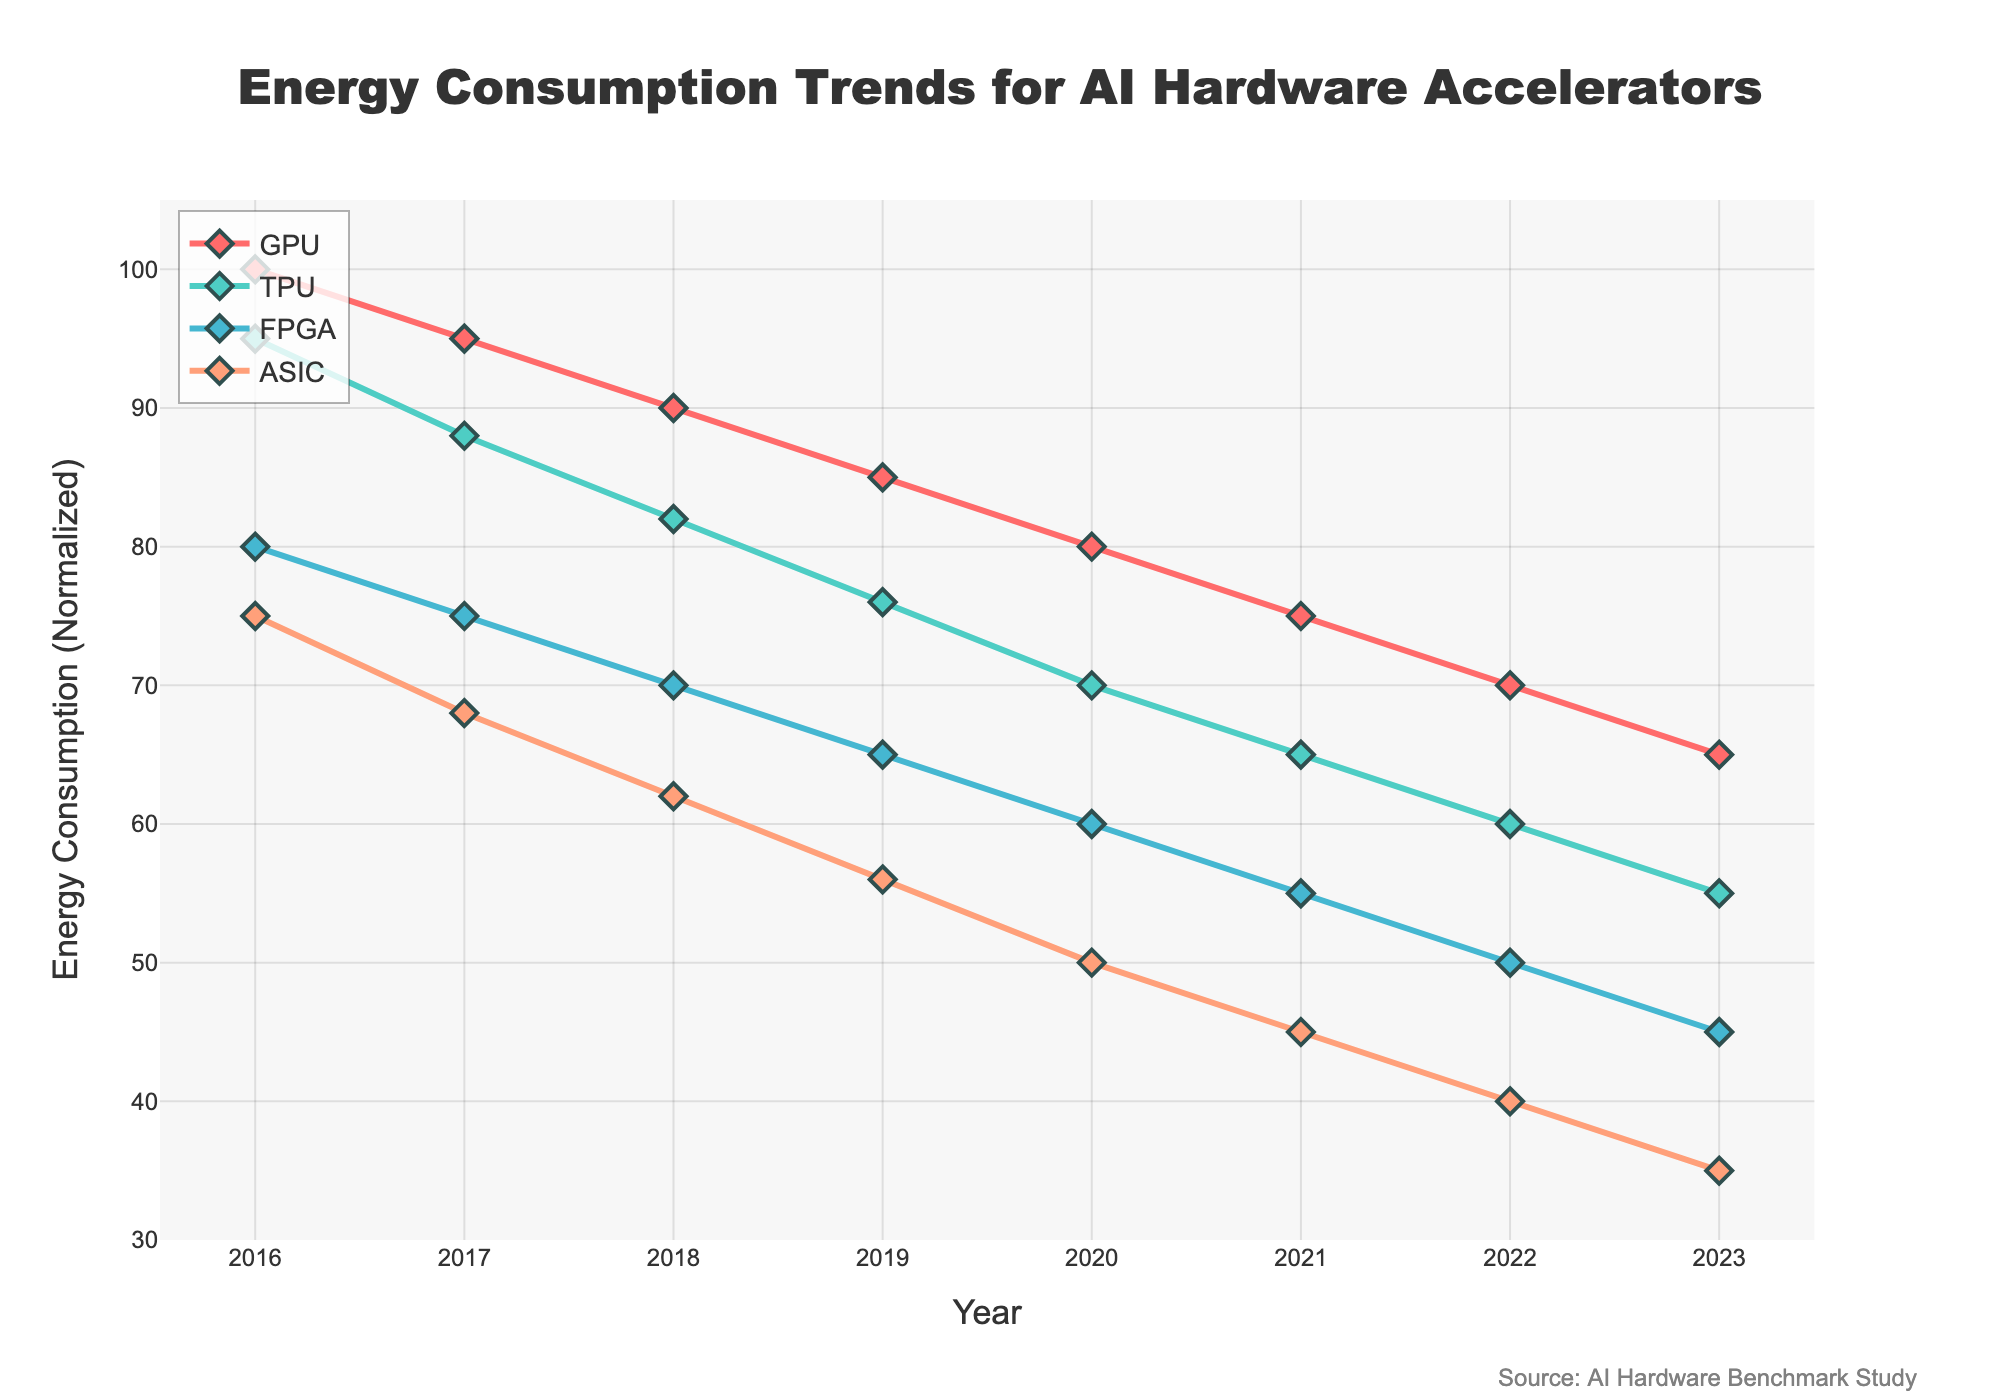What is the trend for energy consumption of GPUs from 2016 to 2023? The energy consumption of GPUs shows a decreasing trend from 2016 to 2023. Specifically, it starts at 100 units in 2016 and falls to 65 units in 2023, with a consistent reduction each year.
Answer: Decreasing Among the four types of hardware accelerators, which one shows the least energy consumption in 2023? In 2023, the ASIC shows the least energy consumption. The energy consumption values in 2023 are 65 for GPU, 55 for TPU, 45 for FPGA, and 35 for ASIC.
Answer: ASIC How much has the energy consumption of ASICs decreased from 2016 to 2023? The energy consumption of ASICs has decreased from 75 units in 2016 to 35 units in 2023. The difference is calculated as 75 - 35 = 40.
Answer: 40 units Which hardware accelerator had the highest energy consumption in 2017, and what was its value? In 2017, the GPU had the highest energy consumption among the four types, with a value of 95 units.
Answer: GPU, 95 units What is the sum of energy consumption values for TPUs and FPGAs in 2020? In 2020, the energy consumption values are 70 units for TPUs and 60 units for FPGAs. The sum is 70 + 60 = 130 units.
Answer: 130 units Between 2018 and 2022, which hardware type shows the smallest reduction in energy consumption? To find this, we need to compare the differences between 2018 and 2022 for each hardware type: GPU (90-70=20), TPU (82-60=22), FPGA (70-50=20), ASIC (62-40=22). Both GPUs and FPGAs show the smallest reduction of 20 units.
Answer: GPU and FPGA What is the average energy consumption of GPUs over the period 2016 to 2023? To find the average: (100 + 95 + 90 + 85 + 80 + 75 + 70 + 65) / 8 = 82.5 units
Answer: 82.5 units Which accelerator has the steepest decline in energy consumption between 2019 and 2020? The decline for each hardware type from 2019 to 2020 is: GPU (85-80=5), TPU (76-70=6), FPGA (65-60=5), ASIC (56-50=6). Both TPU and ASIC have the steepest decline of 6 units.
Answer: TPU and ASIC In what year did FPGAs’ energy consumption first drop below 60 units? The energy consumption of FPGAs first dropped below 60 units in 2021, with a value of 55 units.
Answer: 2021 How do the energy consumption trends for TPUs and FPGAs compare over the period 2016 to 2023? Both TPUs and FPGAs show a consistently decreasing trend from 2016 to 2023. However, the initial values and annual reductions differ. TPUs decrease from 95 to 55 units, and FPGAs decrease from 80 to 45 units, highlighting a greater reduction in TPUs.
Answer: Consistent decrease, greater reduction in TPUs 